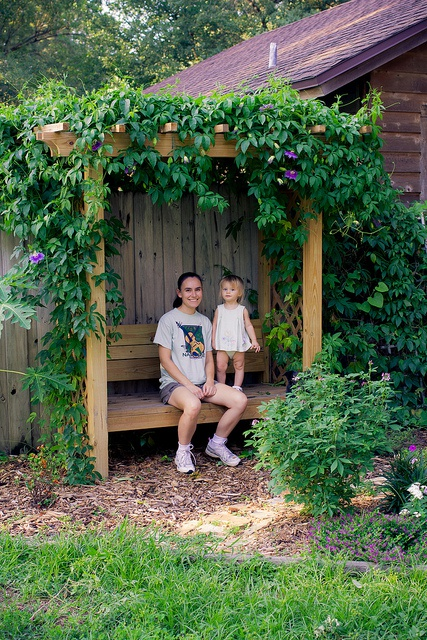Describe the objects in this image and their specific colors. I can see people in olive, lightpink, lightgray, darkgray, and black tones, bench in olive, black, and gray tones, and people in olive, lightgray, lightpink, gray, and darkgray tones in this image. 